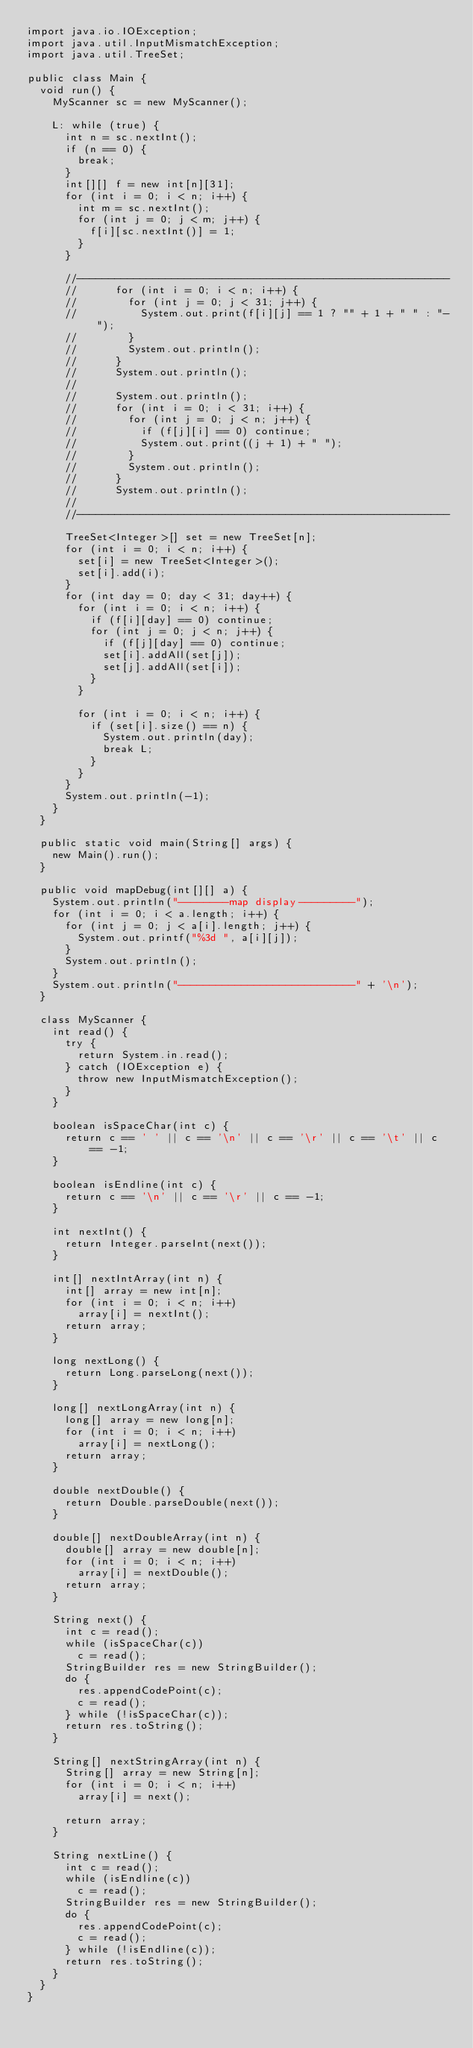<code> <loc_0><loc_0><loc_500><loc_500><_Java_>import java.io.IOException;
import java.util.InputMismatchException;
import java.util.TreeSet;

public class Main {
	void run() {
		MyScanner sc = new MyScanner();

		L: while (true) {
			int n = sc.nextInt();
			if (n == 0) {
				break;
			}
			int[][] f = new int[n][31];
			for (int i = 0; i < n; i++) {
				int m = sc.nextInt();
				for (int j = 0; j < m; j++) {
					f[i][sc.nextInt()] = 1;
				}
			}

			//-----------------------------------------------------------
			//			for (int i = 0; i < n; i++) {
			//				for (int j = 0; j < 31; j++) {
			//					System.out.print(f[i][j] == 1 ? "" + 1 + " " : "- ");
			//				}
			//				System.out.println();
			//			}
			//			System.out.println();
			//
			//			System.out.println();
			//			for (int i = 0; i < 31; i++) {
			//				for (int j = 0; j < n; j++) {
			//					if (f[j][i] == 0) continue;
			//					System.out.print((j + 1) + " ");
			//				}
			//				System.out.println();
			//			}
			//			System.out.println();
			//
			//-----------------------------------------------------------

			TreeSet<Integer>[] set = new TreeSet[n];
			for (int i = 0; i < n; i++) {
				set[i] = new TreeSet<Integer>();
				set[i].add(i);
			}
			for (int day = 0; day < 31; day++) {
				for (int i = 0; i < n; i++) {
					if (f[i][day] == 0) continue;
					for (int j = 0; j < n; j++) {
						if (f[j][day] == 0) continue;
						set[i].addAll(set[j]);
						set[j].addAll(set[i]);
					}
				}
				
				for (int i = 0; i < n; i++) {
					if (set[i].size() == n) {
						System.out.println(day);
						break L;
					}
				}
			}
			System.out.println(-1);
		}
	}

	public static void main(String[] args) {
		new Main().run();
	}

	public void mapDebug(int[][] a) {
		System.out.println("--------map display---------");
		for (int i = 0; i < a.length; i++) {
			for (int j = 0; j < a[i].length; j++) {
				System.out.printf("%3d ", a[i][j]);
			}
			System.out.println();
		}
		System.out.println("----------------------------" + '\n');
	}

	class MyScanner {
		int read() {
			try {
				return System.in.read();
			} catch (IOException e) {
				throw new InputMismatchException();
			}
		}

		boolean isSpaceChar(int c) {
			return c == ' ' || c == '\n' || c == '\r' || c == '\t' || c == -1;
		}

		boolean isEndline(int c) {
			return c == '\n' || c == '\r' || c == -1;
		}

		int nextInt() {
			return Integer.parseInt(next());
		}

		int[] nextIntArray(int n) {
			int[] array = new int[n];
			for (int i = 0; i < n; i++)
				array[i] = nextInt();
			return array;
		}

		long nextLong() {
			return Long.parseLong(next());
		}

		long[] nextLongArray(int n) {
			long[] array = new long[n];
			for (int i = 0; i < n; i++)
				array[i] = nextLong();
			return array;
		}

		double nextDouble() {
			return Double.parseDouble(next());
		}

		double[] nextDoubleArray(int n) {
			double[] array = new double[n];
			for (int i = 0; i < n; i++)
				array[i] = nextDouble();
			return array;
		}

		String next() {
			int c = read();
			while (isSpaceChar(c))
				c = read();
			StringBuilder res = new StringBuilder();
			do {
				res.appendCodePoint(c);
				c = read();
			} while (!isSpaceChar(c));
			return res.toString();
		}

		String[] nextStringArray(int n) {
			String[] array = new String[n];
			for (int i = 0; i < n; i++)
				array[i] = next();

			return array;
		}

		String nextLine() {
			int c = read();
			while (isEndline(c))
				c = read();
			StringBuilder res = new StringBuilder();
			do {
				res.appendCodePoint(c);
				c = read();
			} while (!isEndline(c));
			return res.toString();
		}
	}
}</code> 